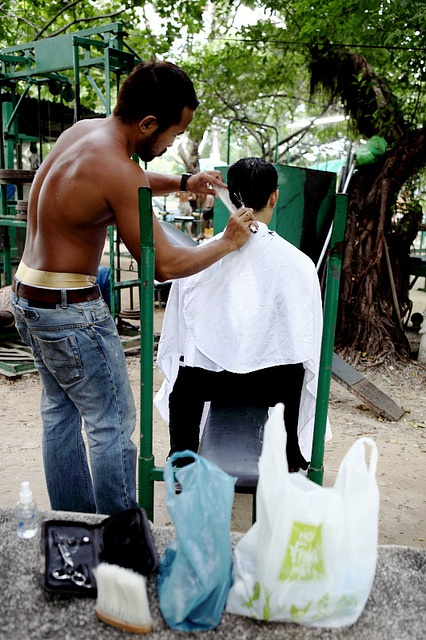Describe the objects in this image and their specific colors. I can see people in darkgreen, black, maroon, gray, and darkgray tones, people in darkgreen, lavender, black, and darkgray tones, scissors in darkgreen, black, gray, darkgray, and lightgray tones, and scissors in darkgreen, black, gray, white, and darkgray tones in this image. 